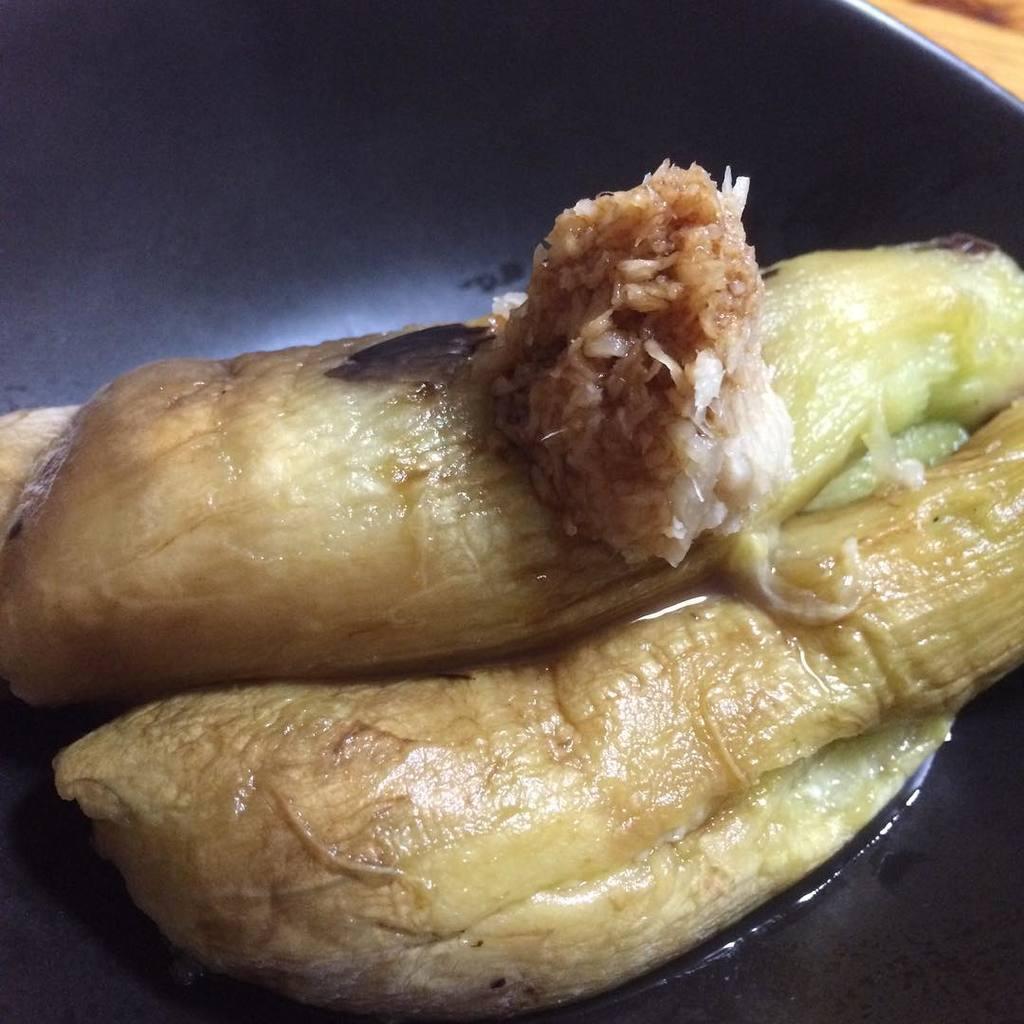Can you describe this image briefly? In this picture we can see food items are placed on a plate and this plate is placed on a surface. 